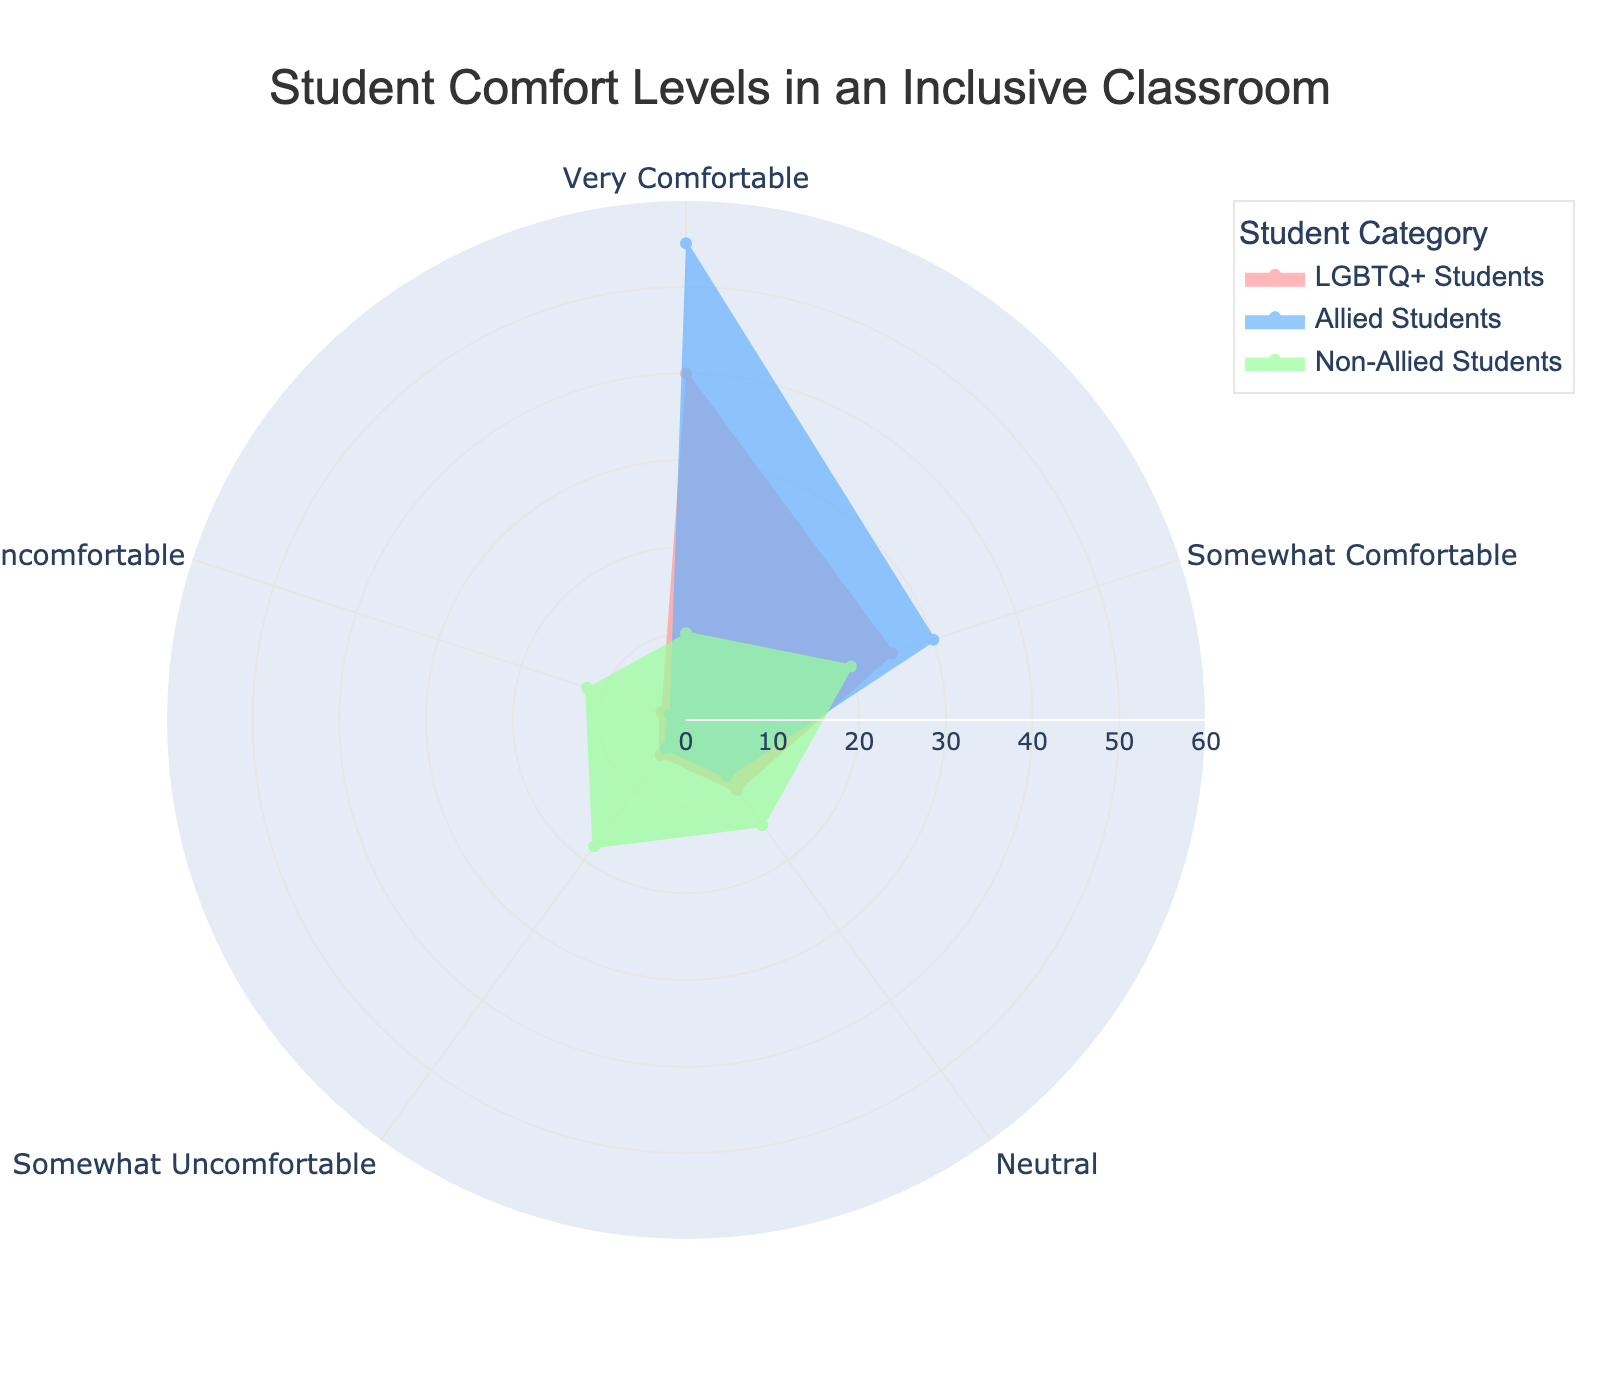What's the title of the figure? The title of a figure is usually found at the top center. It gives a summary of what the figure illustrates. This figure title reads: "Student Comfort Levels in an Inclusive Classroom".
Answer: Student Comfort Levels in an Inclusive Classroom Which student group has the highest count for the "Very Comfortable" level? To find this, we need to look at the radial axis values corresponding to the "Very Comfortable" level for each student group. The "Allied Students" group has the largest radial extent at this level.
Answer: Allied Students How many comfort levels are displayed? The comfort levels can be identified as the distinct categories along the angular axis. Here, the levels are "Very Comfortable", "Somewhat Comfortable", "Neutral", "Somewhat Uncomfortable", and "Very Uncomfortable". Counting these, we find five levels.
Answer: 5 What is the radial range of the polar chart? The radial range describes the extent of the radial axis values, visible in the data. The figure shows values ranging from 0 to 60 on the radial axis.
Answer: 0 to 60 Which student group feels the least "Somewhat Uncomfortable"? To find this, look at the radial axis values for "Somewhat Uncomfortable". The "Allied Students" group shows the lowest value.
Answer: Allied Students What's the total count of students who feel "Neutral"? Sum the radial values for "Neutral" across all groups: LGBTQ+ Students (10) + Allied Students (8) + Non-Allied Students (15) = 33.
Answer: 33 For which comfort level do "LGBTQ+ Students" and "Allied Students" show the biggest difference? Calculate the differences between each level's counts for LGBTQ+ Students and Allied Students: 
- "Very Comfortable" (55 - 40 = 15)
- "Somewhat Comfortable" (30 - 25 = 5)
- "Neutral" (8 - 10 = 2)
- "Somewhat Uncomfortable" (4 - 5 = 1)
- "Very Uncomfortable" (2 - 3 = 1)
The biggest difference is at "Very Comfortable".
Answer: Very Comfortable How many "Non-Allied Students" feel either "Somewhat Uncomfortable" or "Very Uncomfortable"? Add the radial values for "Somewhat Uncomfortable" and "Very Uncomfortable" for Non-Allied Students: 18 + 12 = 30.
Answer: 30 Which comfort level has the combined highest count for all students? Summing the counts for each level across all groups:
- Very Comfortable: 40 + 55 + 10 = 105
- Somewhat Comfortable: 25 + 30 + 20 = 75
- Neutral: 10 + 8 + 15 = 33
- Somewhat Uncomfortable: 5 + 4 + 18 = 27
- Very Uncomfortable: 3 + 2 + 12 = 17
"Very Comfortable" has the highest total.
Answer: Very Comfortable What is the average count of students feeling "Very Uncomfortable" across all groups? Add the counts for "Very Uncomfortable" across all groups and divide by the number of groups: (3 + 2 + 12) / 3 = 17 / 3 ≈ 5.67.
Answer: 5.67 